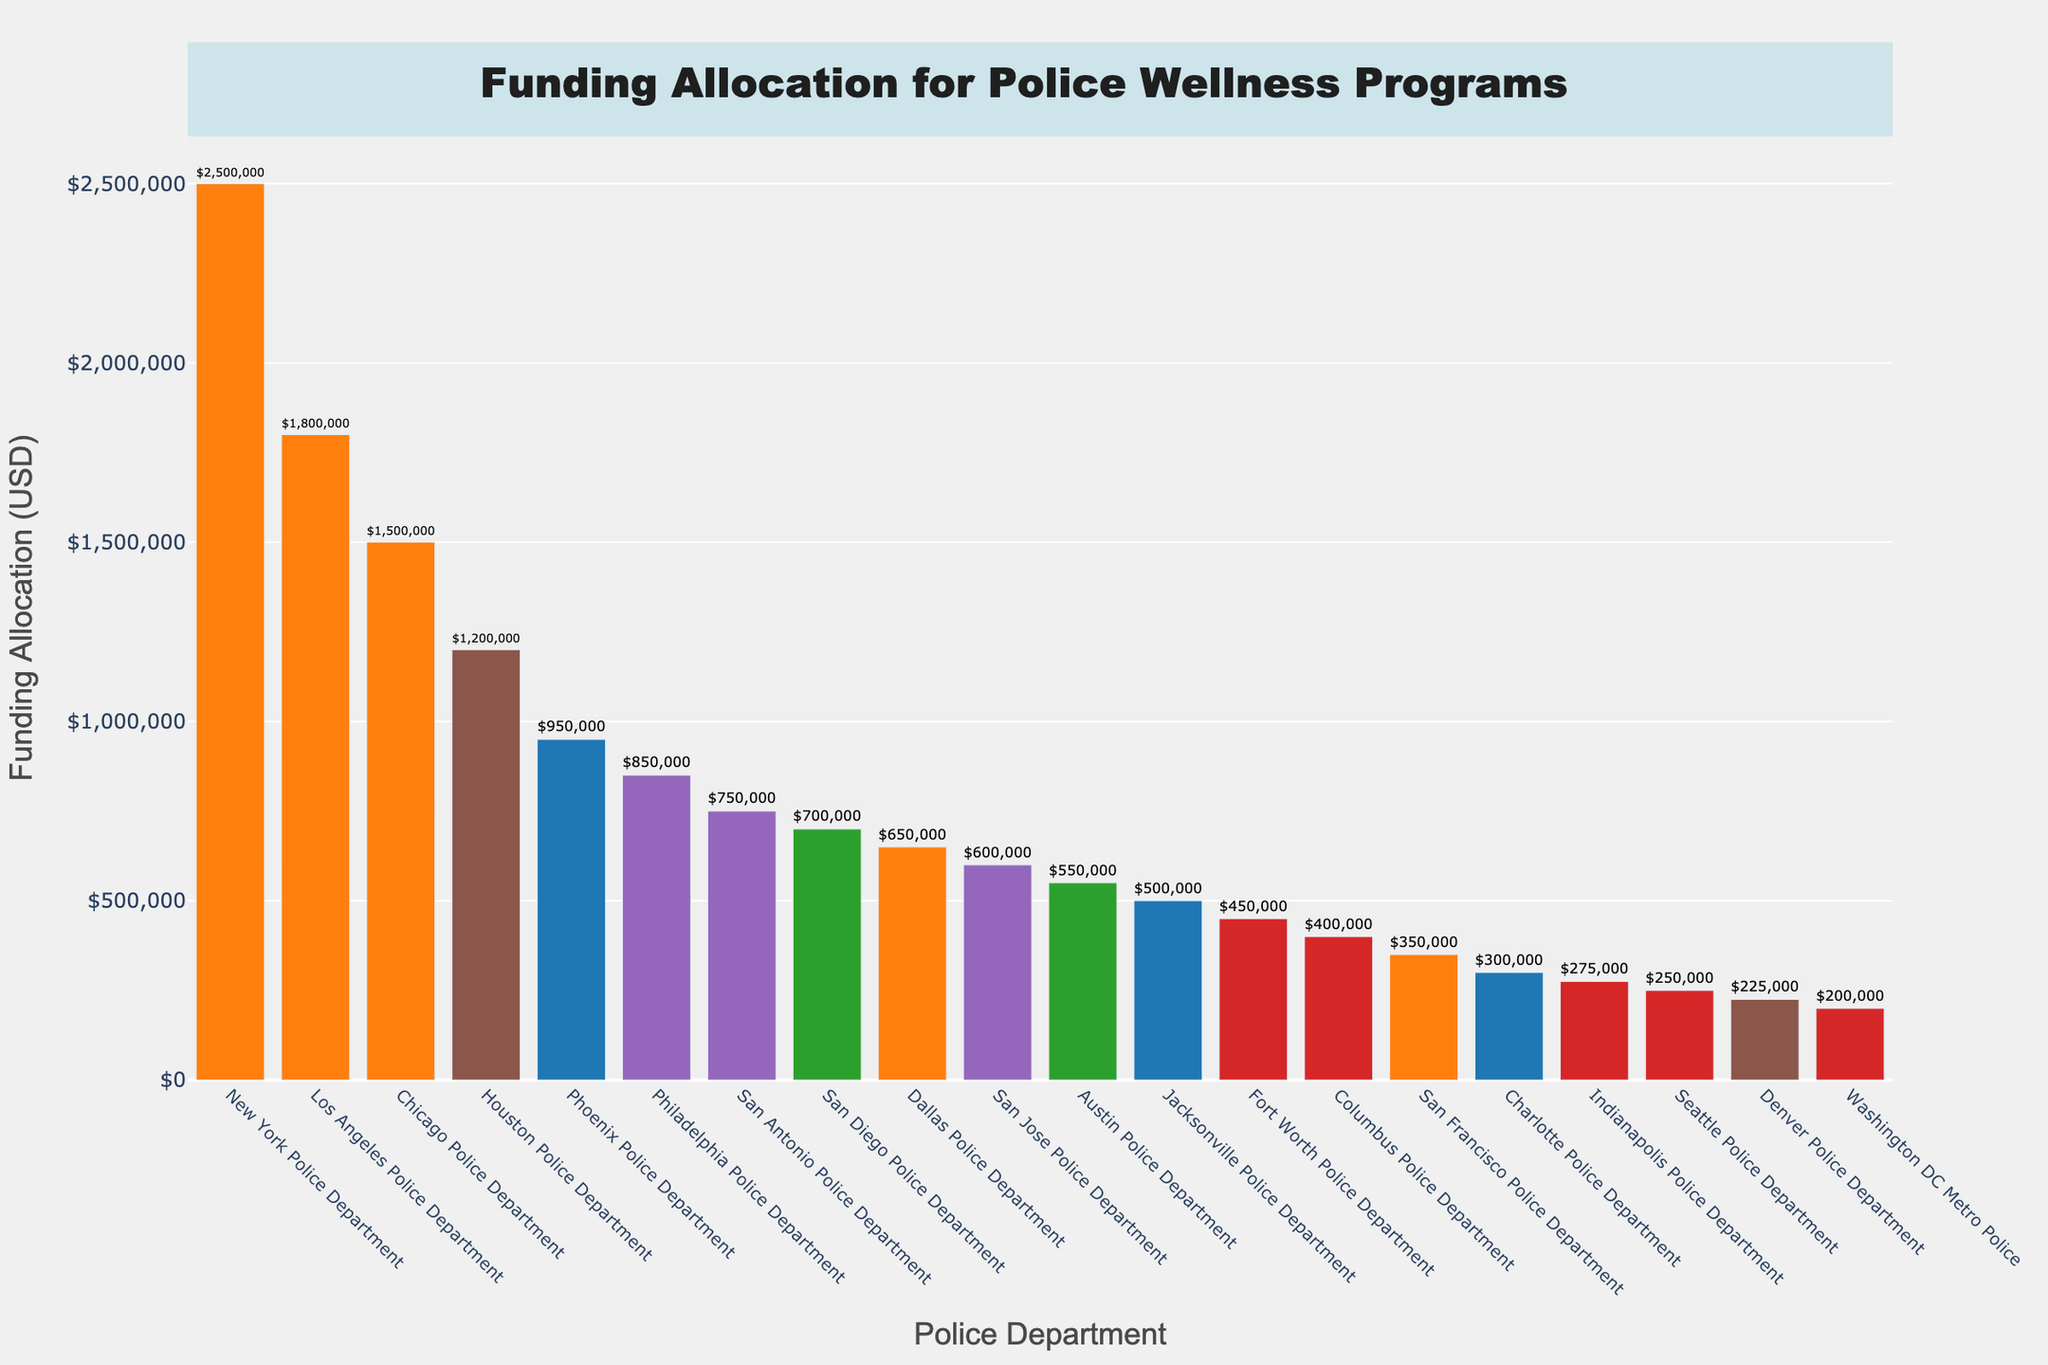Which police department received the highest funding allocation for wellness programs? The bar representing the New York Police Department is the tallest, indicating it received the highest funding allocation.
Answer: New York Police Department What is the difference in funding allocation between the Houston Police Department and the Phoenix Police Department? The Houston Police Department received $1,200,000 and the Phoenix Police Department received $950,000. The difference is $1,200,000 - $950,000.
Answer: $250,000 Which departments received less than $500,000? By observing the bars of departments at the lower end of the chart, we can see that the Jacksonville, Fort Worth, Columbus, San Francisco, Charlotte, Indianapolis, Seattle, Denver, and Washington DC Metro Police Departments received less than $500,000.
Answer: Jacksonville, Fort Worth, Columbus, San Francisco, Charlotte, Indianapolis, Seattle, Denver, Washington DC Metro Police Compare the funding allocation between the San Diego Police Department and the San Jose Police Department. Which one received more? The San Diego Police Department received $700,000, while the San Jose Police Department received $600,000.
Answer: San Diego Police Department What is the average funding allocation for wellness programs across all departments listed? Sum all the funding allocations and divide by the number of departments (20). Calculation: (2500000 + 1800000 + 1500000 + 1200000 + 950000 + 850000 + 750000 + 700000 + 650000 + 600000 + 550000 + 500000 + 450000 + 400000 + 350000 + 300000 + 275000 + 250000 + 225000 + 200000) / 20 = 74250000 / 20 = 3,712,500 / 20 = $1,856,250
Answer: $1,856,250 What is the median funding allocation? List the funding amounts in ascending order and find the middle value. Since there are 20 departments, the median is the average of the 10th and 11th values: (600,000 + 650,000) / 2 = $625,000.
Answer: $625,000 Which departments received the same funding allocation amounts? From observing the chart, no two departments received exactly the same funding allocation amounts.
Answer: None How much more funding did the New York Police Department receive compared to the Philadelphia Police Department? The New York Police Department received $2,500,000, and the Philadelphia Police Department received $850,000. The difference is $2,500,000 - $850,000.
Answer: $1,650,000 Which department received the least funding allocation, and how much was it? The Washington DC Metro Police Department received the least funding allocation, as indicated by the shortest bar, which is $200,000.
Answer: Washington DC Metro Police Department, $200,000 